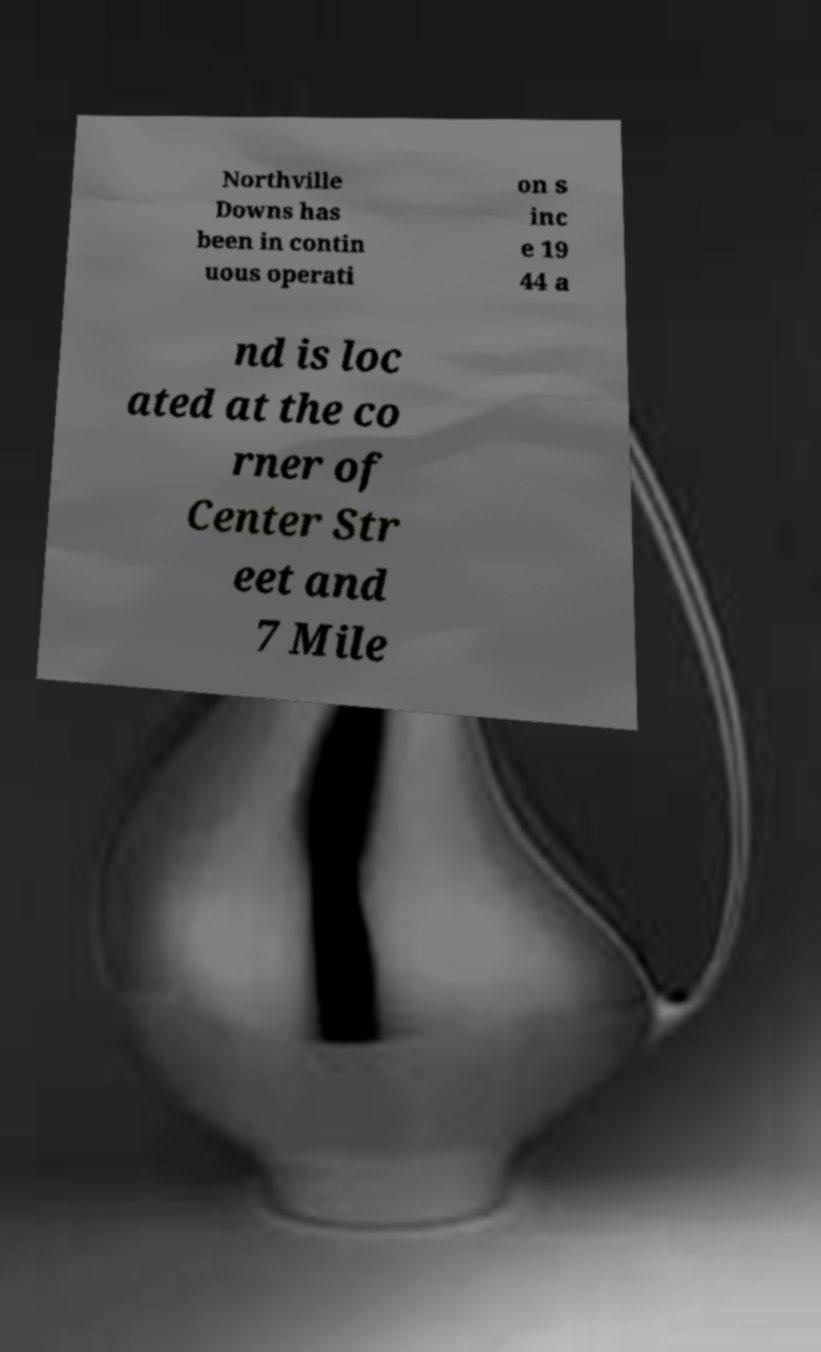Can you accurately transcribe the text from the provided image for me? Northville Downs has been in contin uous operati on s inc e 19 44 a nd is loc ated at the co rner of Center Str eet and 7 Mile 